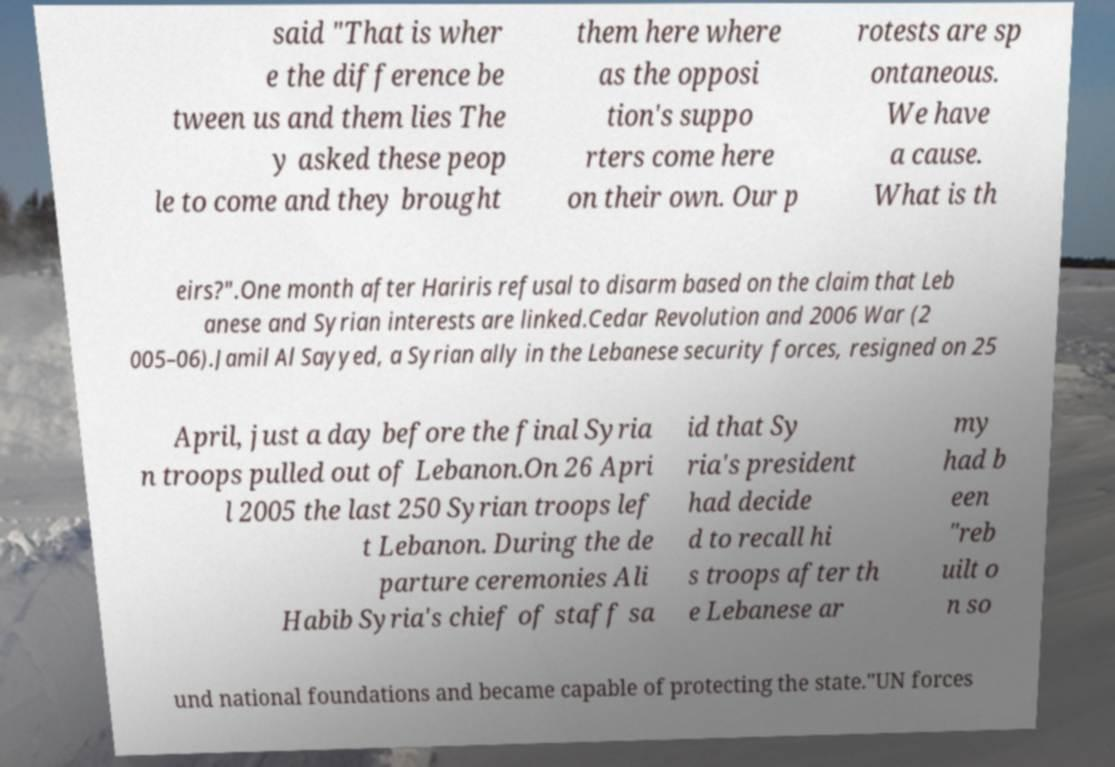Please read and relay the text visible in this image. What does it say? said "That is wher e the difference be tween us and them lies The y asked these peop le to come and they brought them here where as the opposi tion's suppo rters come here on their own. Our p rotests are sp ontaneous. We have a cause. What is th eirs?".One month after Hariris refusal to disarm based on the claim that Leb anese and Syrian interests are linked.Cedar Revolution and 2006 War (2 005–06).Jamil Al Sayyed, a Syrian ally in the Lebanese security forces, resigned on 25 April, just a day before the final Syria n troops pulled out of Lebanon.On 26 Apri l 2005 the last 250 Syrian troops lef t Lebanon. During the de parture ceremonies Ali Habib Syria's chief of staff sa id that Sy ria's president had decide d to recall hi s troops after th e Lebanese ar my had b een "reb uilt o n so und national foundations and became capable of protecting the state."UN forces 